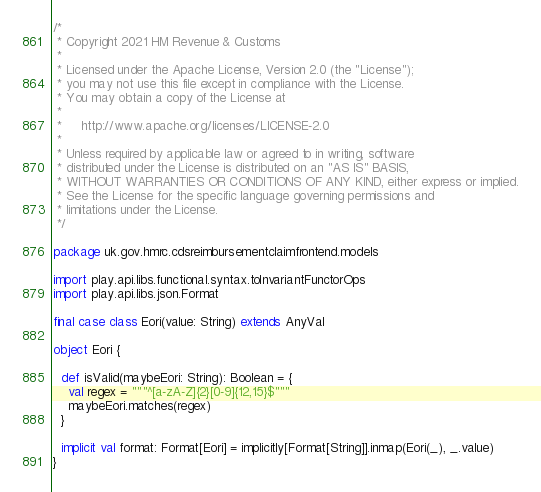<code> <loc_0><loc_0><loc_500><loc_500><_Scala_>/*
 * Copyright 2021 HM Revenue & Customs
 *
 * Licensed under the Apache License, Version 2.0 (the "License");
 * you may not use this file except in compliance with the License.
 * You may obtain a copy of the License at
 *
 *     http://www.apache.org/licenses/LICENSE-2.0
 *
 * Unless required by applicable law or agreed to in writing, software
 * distributed under the License is distributed on an "AS IS" BASIS,
 * WITHOUT WARRANTIES OR CONDITIONS OF ANY KIND, either express or implied.
 * See the License for the specific language governing permissions and
 * limitations under the License.
 */

package uk.gov.hmrc.cdsreimbursementclaimfrontend.models

import play.api.libs.functional.syntax.toInvariantFunctorOps
import play.api.libs.json.Format

final case class Eori(value: String) extends AnyVal

object Eori {

  def isValid(maybeEori: String): Boolean = {
    val regex = """^[a-zA-Z]{2}[0-9]{12,15}$"""
    maybeEori.matches(regex)
  }

  implicit val format: Format[Eori] = implicitly[Format[String]].inmap(Eori(_), _.value)
}
</code> 